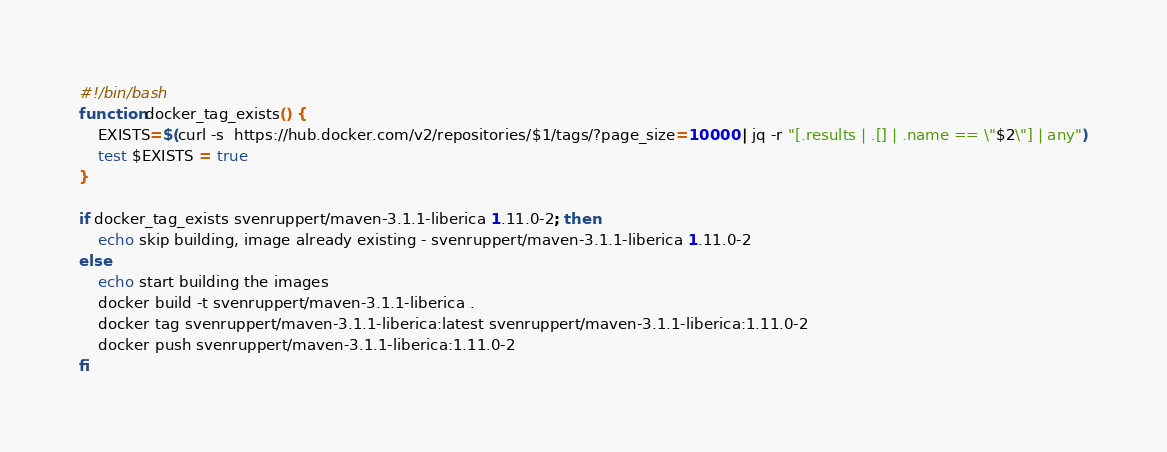Convert code to text. <code><loc_0><loc_0><loc_500><loc_500><_Bash_>#!/bin/bash
function docker_tag_exists() {
    EXISTS=$(curl -s  https://hub.docker.com/v2/repositories/$1/tags/?page_size=10000 | jq -r "[.results | .[] | .name == \"$2\"] | any")
    test $EXISTS = true
}

if docker_tag_exists svenruppert/maven-3.1.1-liberica 1.11.0-2; then
    echo skip building, image already existing - svenruppert/maven-3.1.1-liberica 1.11.0-2
else
    echo start building the images
    docker build -t svenruppert/maven-3.1.1-liberica .
    docker tag svenruppert/maven-3.1.1-liberica:latest svenruppert/maven-3.1.1-liberica:1.11.0-2
    docker push svenruppert/maven-3.1.1-liberica:1.11.0-2
fi</code> 